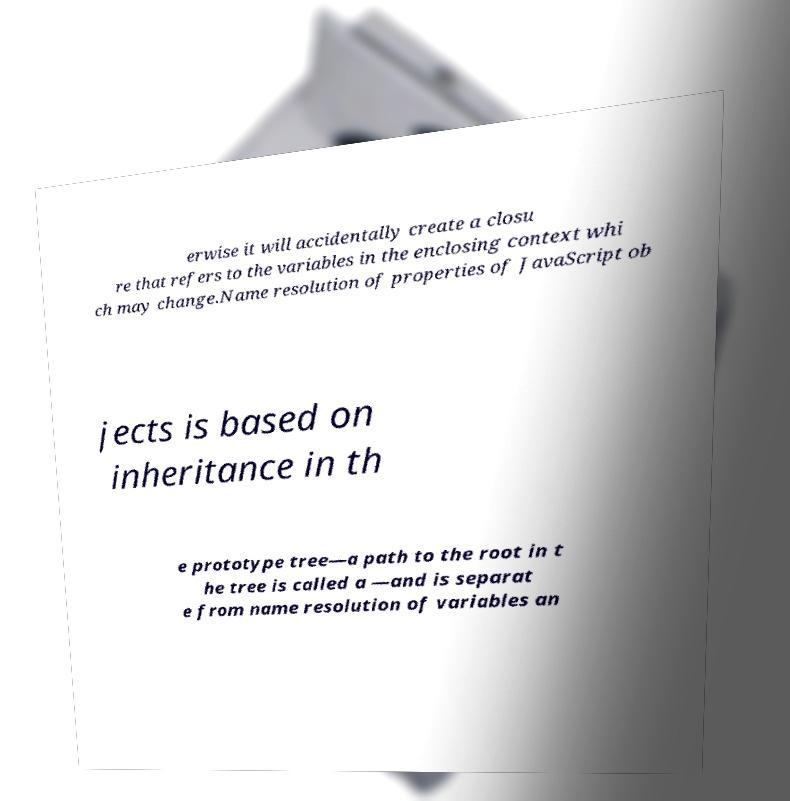The text mentions 'prototype tree'. Can you clarify what that means? In JavaScript, the prototype tree or prototype chain is a mechanism in which objects inherit features from one another. Every object can have a prototype, and a prototyped object can have its own prototype, forming a 'chain'. This inheritance chain up to the root (where the prototype is null) is what we call the prototype tree. It's crucial for property lookups; if a property is not found directly on an object, JavaScript looks up the prototype chain to find it. 